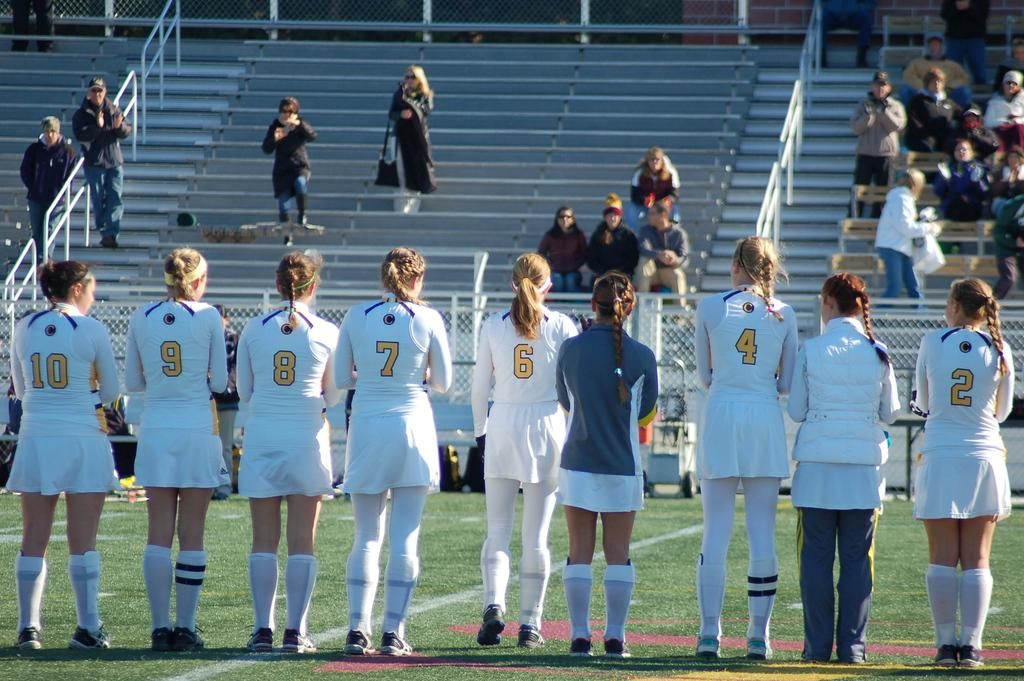<image>
Present a compact description of the photo's key features. Player number two is the last girl in line on the right. 